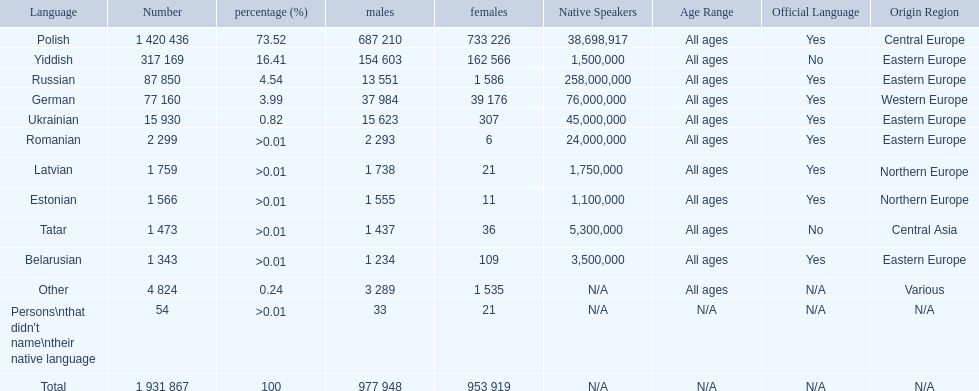What is the percentage of polish speakers? 73.52. What is the next highest percentage of speakers? 16.41. What language is this percentage? Yiddish. 